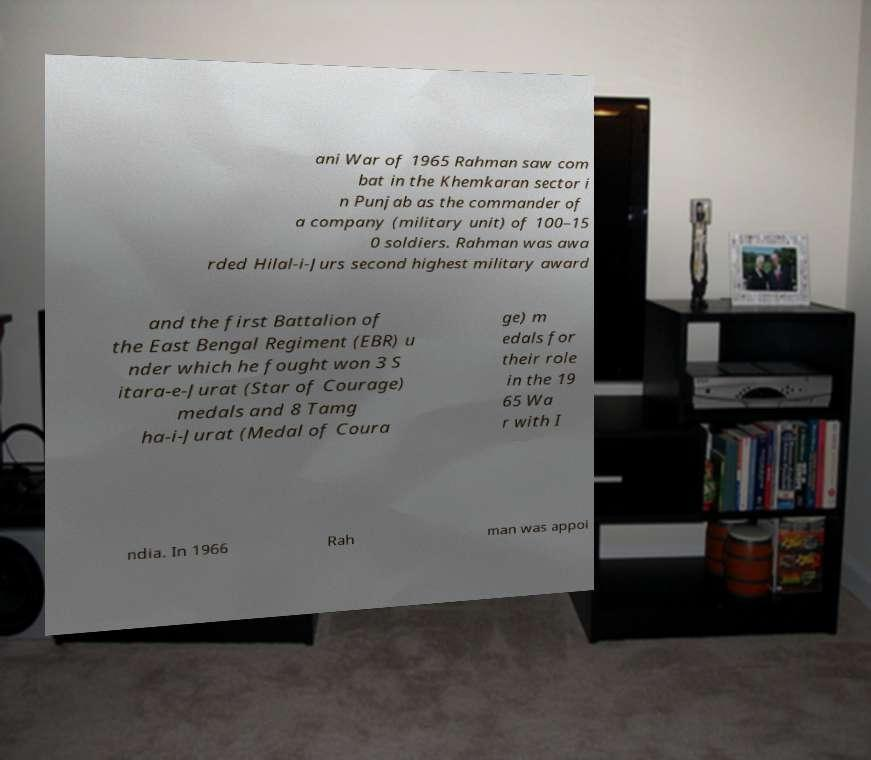There's text embedded in this image that I need extracted. Can you transcribe it verbatim? ani War of 1965 Rahman saw com bat in the Khemkaran sector i n Punjab as the commander of a company (military unit) of 100–15 0 soldiers. Rahman was awa rded Hilal-i-Jurs second highest military award and the first Battalion of the East Bengal Regiment (EBR) u nder which he fought won 3 S itara-e-Jurat (Star of Courage) medals and 8 Tamg ha-i-Jurat (Medal of Coura ge) m edals for their role in the 19 65 Wa r with I ndia. In 1966 Rah man was appoi 